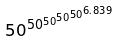Convert formula to latex. <formula><loc_0><loc_0><loc_500><loc_500>5 0 ^ { 5 0 ^ { 5 0 ^ { 5 0 ^ { 5 0 ^ { 6 . 8 3 9 } } } } }</formula> 